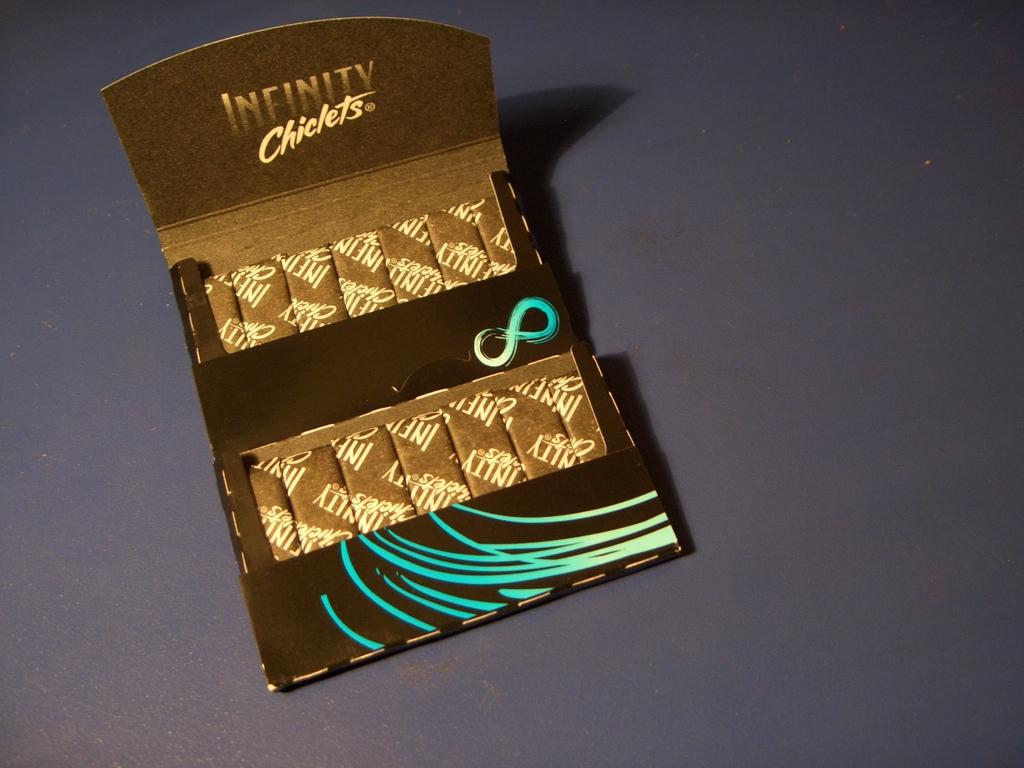Whats that sign on the bar?
Keep it short and to the point. Unanswerable. What company made this product?
Give a very brief answer. Infinity. 